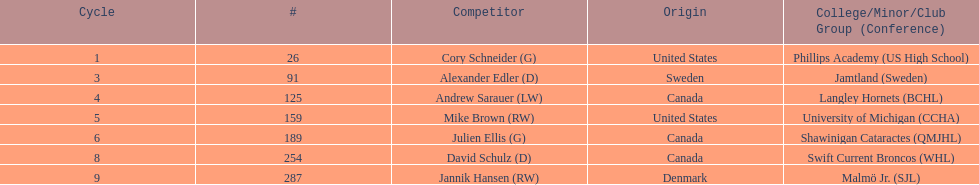Who are the players? Cory Schneider (G), Alexander Edler (D), Andrew Sarauer (LW), Mike Brown (RW), Julien Ellis (G), David Schulz (D), Jannik Hansen (RW). Of those, who is from denmark? Jannik Hansen (RW). 